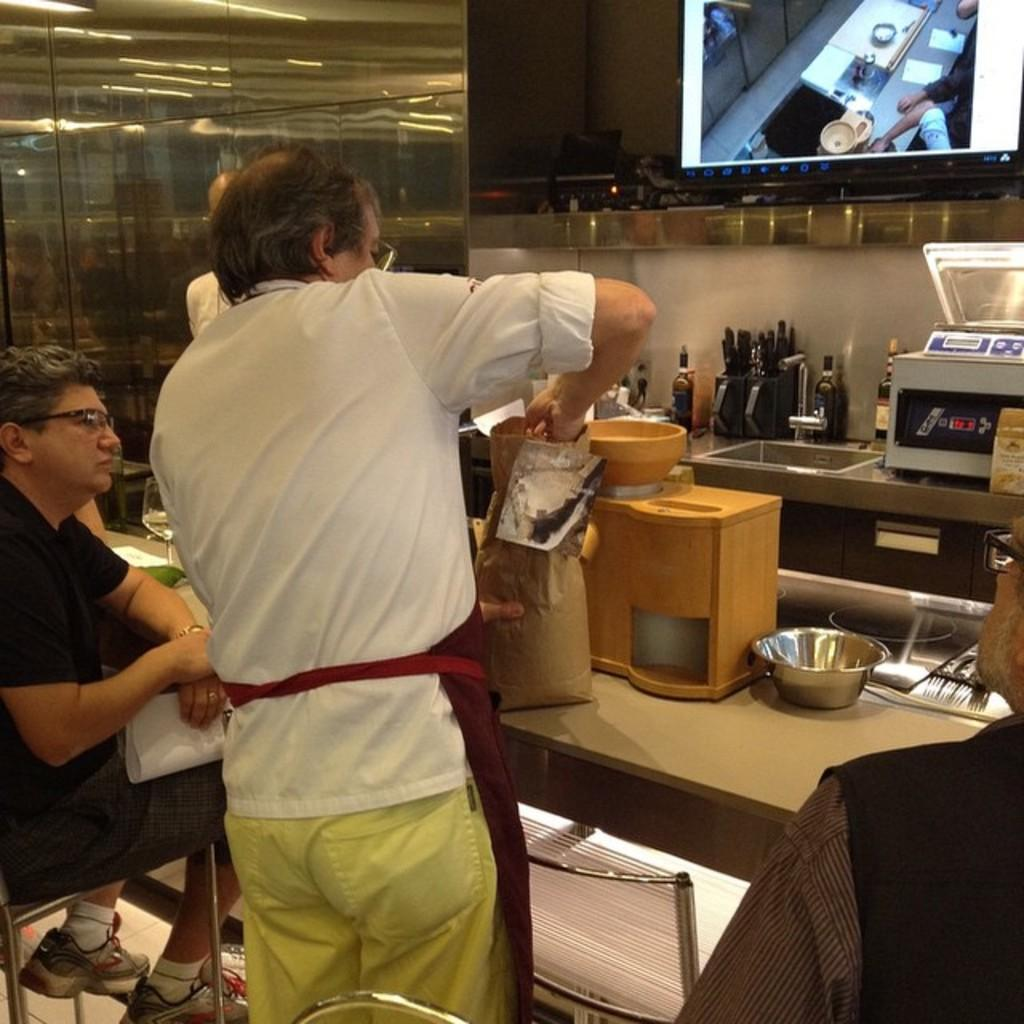How many people are in the image? There are people in the image, specifically a man sitting and another man standing. What is the position of the man in the image? The man is sitting in the image. What is the other man doing in the image? The other man is standing in the image. What can be seen in the background of the image? There are utensils and a screen in the background of the image. What type of plastic material is being used by the zephyr in the image? There is no zephyr or plastic material present in the image. What is the fang doing in the image? There is no fang present in the image. 